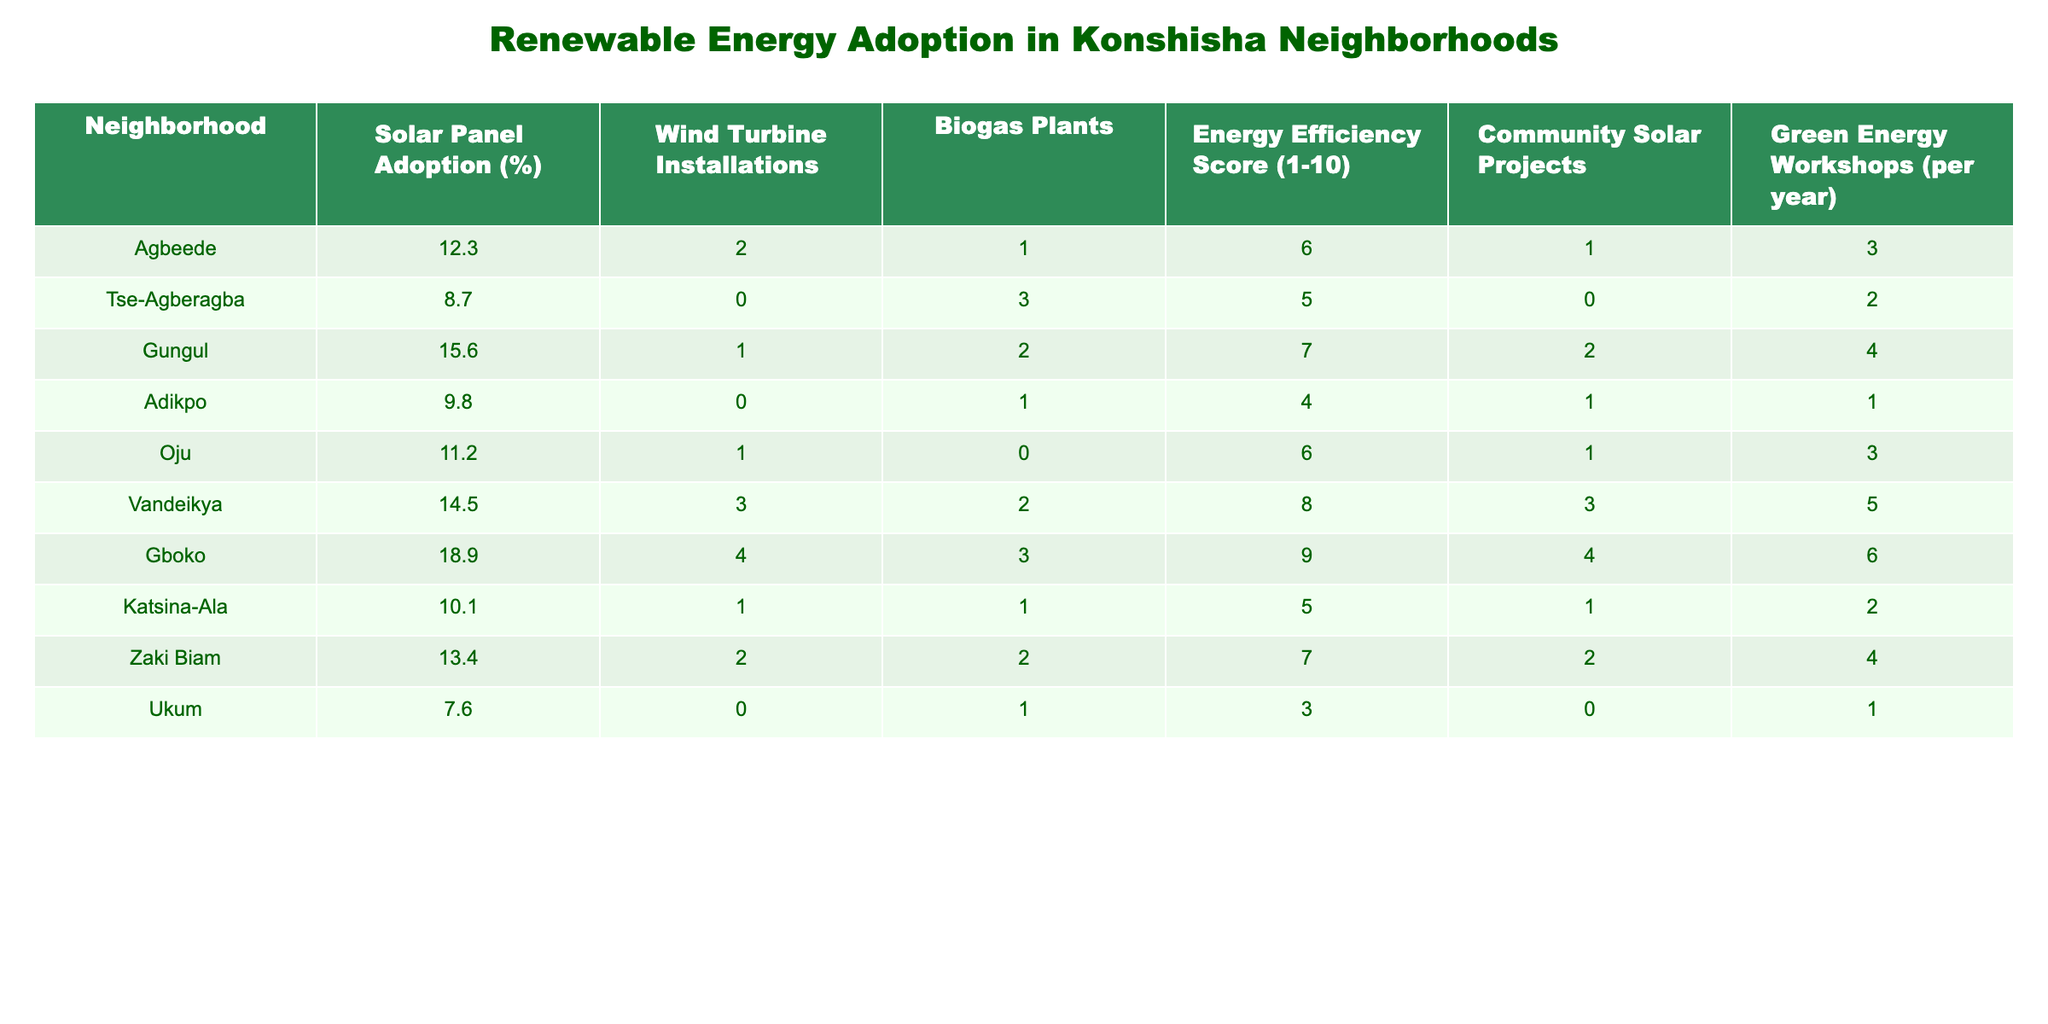What neighborhood has the highest solar panel adoption rate? By reviewing the 'Solar Panel Adoption (%)' column, I see that Gboko has the highest percentage at 18.9%.
Answer: Gboko How many neighborhoods have more than 2 wind turbine installations? Looking at the 'Wind Turbine Installations' column, I count Vandeikya (3), Gboko (4), and Agbeede (2) as the neighborhoods with installations greater than 2. Therefore, there are 3 neighborhoods with more than 2 installations.
Answer: 3 What is the average energy efficiency score of all neighborhoods? To find the average, I sum the 'Energy Efficiency Score (1-10)' values: (6 + 5 + 7 + 4 + 6 + 8 + 9 + 5 + 7 + 3) = 60. There are 10 neighborhoods, dividing 60 by 10 gives an average score of 6.
Answer: 6 Is it true that Ukum has more community solar projects than Tse-Agberagba? Looking at the 'Community Solar Projects' column, Ukum has 0 projects while Tse-Agberagba has 0 as well. Therefore, the statement is false.
Answer: No Which neighborhood has the lowest adoption rate of solar panels and what is the rate? By examining the 'Solar Panel Adoption (%)' column, I find Ukum has the lowest adoption rate at 7.6%.
Answer: Ukum, 7.6% What is the total number of biogas plants installed across all neighborhoods? I sum the values from the 'Biogas Plants' column: (1 + 3 + 2 + 1 + 0 + 2 + 3 + 1 + 2 + 1) = 16. The total number of biogas plants is 16.
Answer: 16 If we consider the neighborhoods with an energy efficiency score of 8 or higher, how many have solar panel adoption rates above 10%? The eligible neighborhoods based on the energy efficiency score are Vandeikya (8) and Gboko (9). Checking their solar panel adoption rates, Vandeikya has 14.5% and Gboko has 18.9%, so both meet the criteria, resulting in 2 neighborhoods.
Answer: 2 Which neighborhood has the most green energy workshops held per year? Referring to the 'Green Energy Workshops (per year)' column, I find that Gboko hosts the most workshops with 6 per year.
Answer: Gboko, 6 